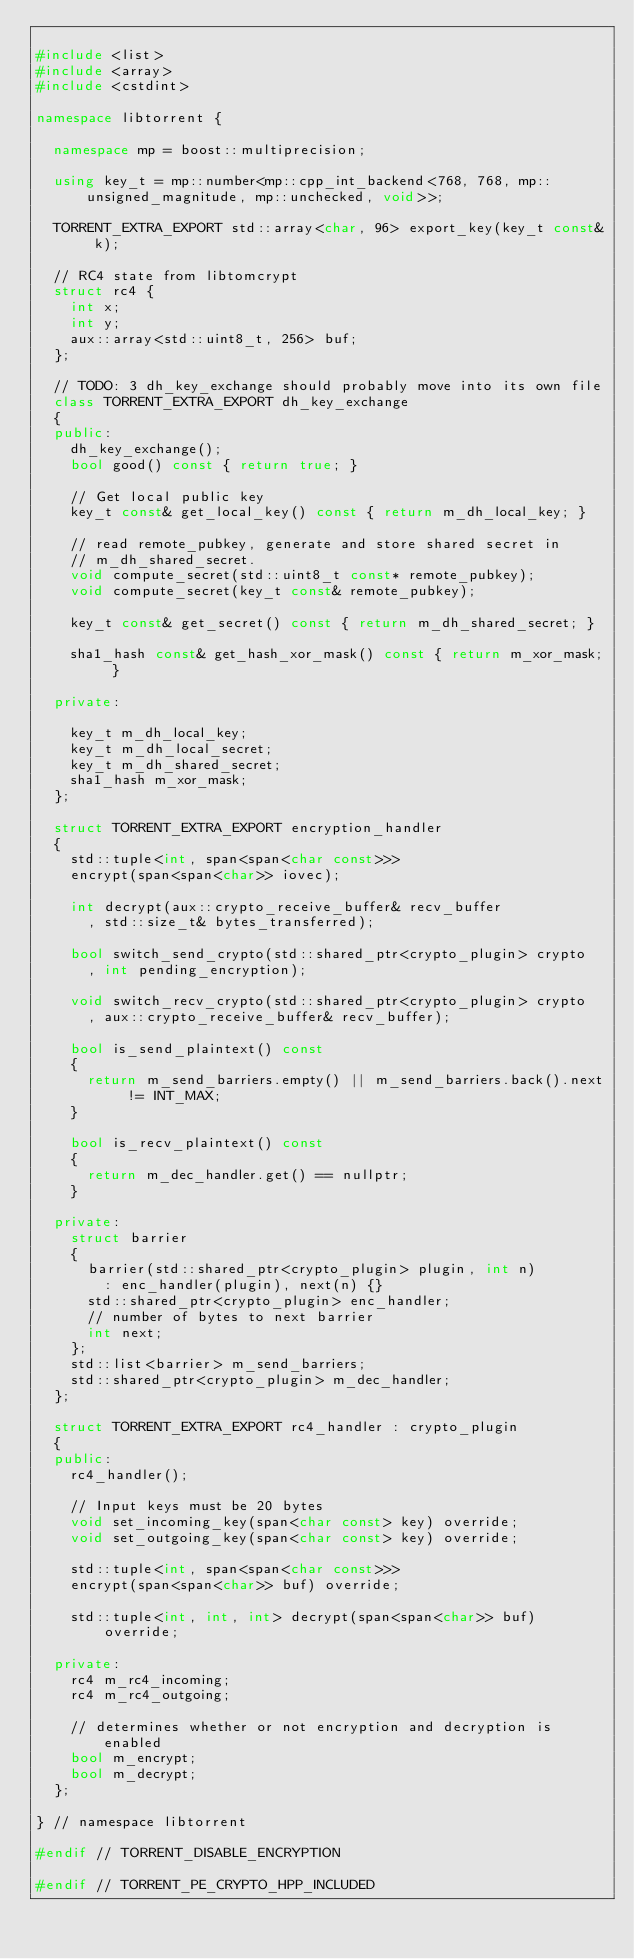Convert code to text. <code><loc_0><loc_0><loc_500><loc_500><_C++_>
#include <list>
#include <array>
#include <cstdint>

namespace libtorrent {

	namespace mp = boost::multiprecision;

	using key_t = mp::number<mp::cpp_int_backend<768, 768, mp::unsigned_magnitude, mp::unchecked, void>>;

	TORRENT_EXTRA_EXPORT std::array<char, 96> export_key(key_t const& k);

	// RC4 state from libtomcrypt
	struct rc4 {
		int x;
		int y;
		aux::array<std::uint8_t, 256> buf;
	};

	// TODO: 3 dh_key_exchange should probably move into its own file
	class TORRENT_EXTRA_EXPORT dh_key_exchange
	{
	public:
		dh_key_exchange();
		bool good() const { return true; }

		// Get local public key
		key_t const& get_local_key() const { return m_dh_local_key; }

		// read remote_pubkey, generate and store shared secret in
		// m_dh_shared_secret.
		void compute_secret(std::uint8_t const* remote_pubkey);
		void compute_secret(key_t const& remote_pubkey);

		key_t const& get_secret() const { return m_dh_shared_secret; }

		sha1_hash const& get_hash_xor_mask() const { return m_xor_mask; }

	private:

		key_t m_dh_local_key;
		key_t m_dh_local_secret;
		key_t m_dh_shared_secret;
		sha1_hash m_xor_mask;
	};

	struct TORRENT_EXTRA_EXPORT encryption_handler
	{
		std::tuple<int, span<span<char const>>>
		encrypt(span<span<char>> iovec);

		int decrypt(aux::crypto_receive_buffer& recv_buffer
			, std::size_t& bytes_transferred);

		bool switch_send_crypto(std::shared_ptr<crypto_plugin> crypto
			, int pending_encryption);

		void switch_recv_crypto(std::shared_ptr<crypto_plugin> crypto
			, aux::crypto_receive_buffer& recv_buffer);

		bool is_send_plaintext() const
		{
			return m_send_barriers.empty() || m_send_barriers.back().next != INT_MAX;
		}

		bool is_recv_plaintext() const
		{
			return m_dec_handler.get() == nullptr;
		}

	private:
		struct barrier
		{
			barrier(std::shared_ptr<crypto_plugin> plugin, int n)
				: enc_handler(plugin), next(n) {}
			std::shared_ptr<crypto_plugin> enc_handler;
			// number of bytes to next barrier
			int next;
		};
		std::list<barrier> m_send_barriers;
		std::shared_ptr<crypto_plugin> m_dec_handler;
	};

	struct TORRENT_EXTRA_EXPORT rc4_handler : crypto_plugin
	{
	public:
		rc4_handler();

		// Input keys must be 20 bytes
		void set_incoming_key(span<char const> key) override;
		void set_outgoing_key(span<char const> key) override;

		std::tuple<int, span<span<char const>>>
		encrypt(span<span<char>> buf) override;

		std::tuple<int, int, int> decrypt(span<span<char>> buf) override;

	private:
		rc4 m_rc4_incoming;
		rc4 m_rc4_outgoing;

		// determines whether or not encryption and decryption is enabled
		bool m_encrypt;
		bool m_decrypt;
	};

} // namespace libtorrent

#endif // TORRENT_DISABLE_ENCRYPTION

#endif // TORRENT_PE_CRYPTO_HPP_INCLUDED
</code> 